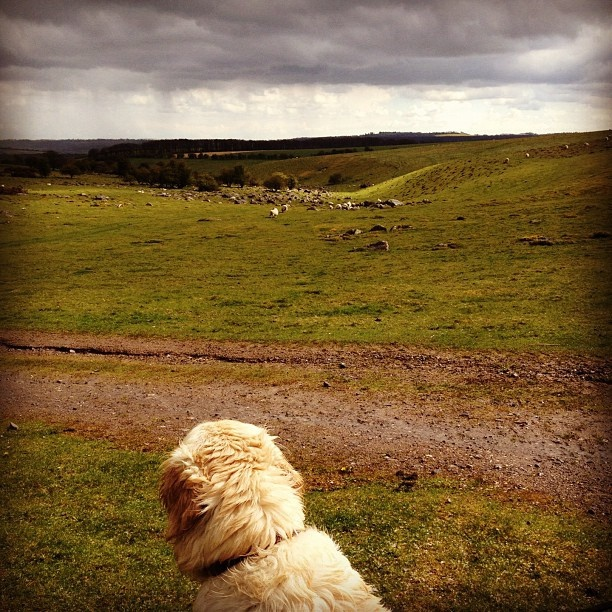Describe the objects in this image and their specific colors. I can see dog in black, tan, lightyellow, and brown tones, sheep in black, olive, gray, and maroon tones, sheep in black, olive, tan, lightyellow, and maroon tones, sheep in black, olive, and maroon tones, and sheep in black, maroon, and olive tones in this image. 